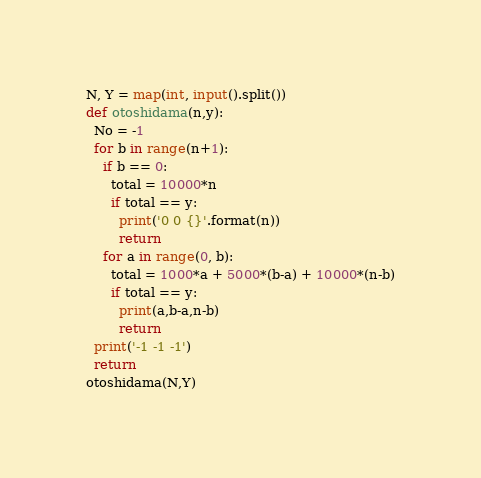<code> <loc_0><loc_0><loc_500><loc_500><_Python_>N, Y = map(int, input().split())
def otoshidama(n,y):
  No = -1
  for b in range(n+1):
    if b == 0:
      total = 10000*n
      if total == y:
        print('0 0 {}'.format(n))
        return
    for a in range(0, b):
      total = 1000*a + 5000*(b-a) + 10000*(n-b)
      if total == y:
        print(a,b-a,n-b)
        return
  print('-1 -1 -1')
  return
otoshidama(N,Y)</code> 